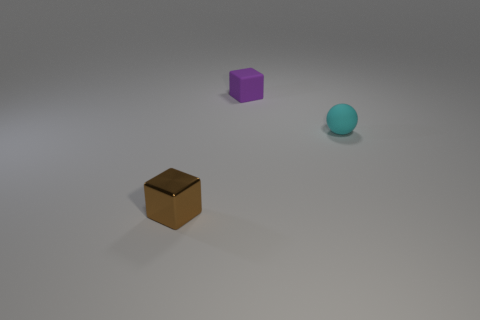Add 3 green matte cylinders. How many objects exist? 6 Subtract all small purple rubber things. Subtract all tiny cyan objects. How many objects are left? 1 Add 3 tiny brown metallic objects. How many tiny brown metallic objects are left? 4 Add 3 small brown blocks. How many small brown blocks exist? 4 Subtract all purple blocks. How many blocks are left? 1 Subtract 0 cyan cylinders. How many objects are left? 3 Subtract all spheres. How many objects are left? 2 Subtract all cyan cubes. Subtract all yellow cylinders. How many cubes are left? 2 Subtract all red cubes. How many gray balls are left? 0 